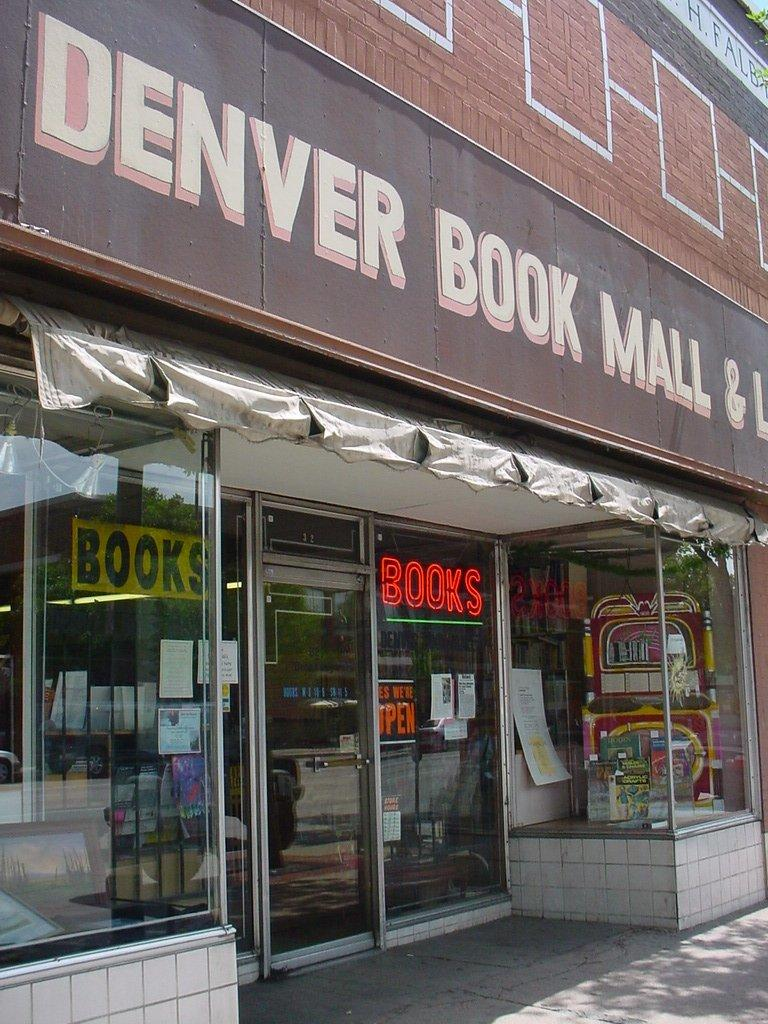<image>
Render a clear and concise summary of the photo. The Denver Book Mall is one of the stores on this street. 